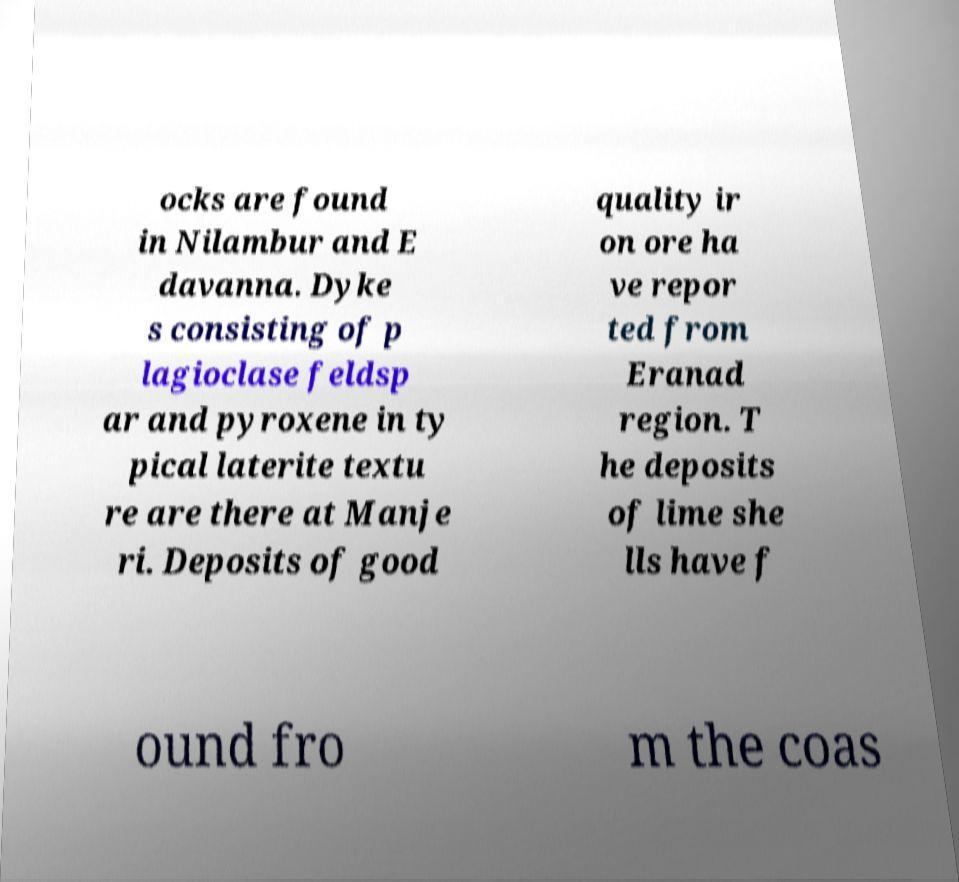What messages or text are displayed in this image? I need them in a readable, typed format. ocks are found in Nilambur and E davanna. Dyke s consisting of p lagioclase feldsp ar and pyroxene in ty pical laterite textu re are there at Manje ri. Deposits of good quality ir on ore ha ve repor ted from Eranad region. T he deposits of lime she lls have f ound fro m the coas 